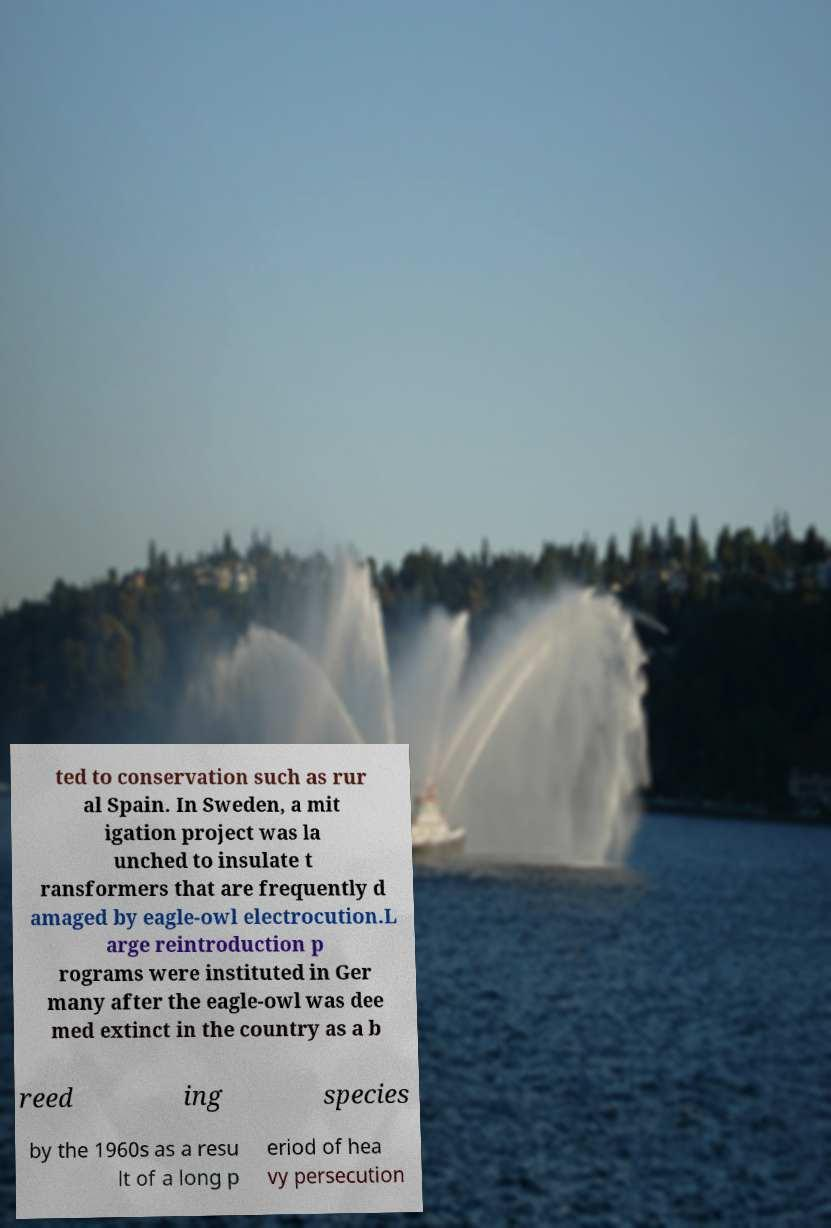Please read and relay the text visible in this image. What does it say? ted to conservation such as rur al Spain. In Sweden, a mit igation project was la unched to insulate t ransformers that are frequently d amaged by eagle-owl electrocution.L arge reintroduction p rograms were instituted in Ger many after the eagle-owl was dee med extinct in the country as a b reed ing species by the 1960s as a resu lt of a long p eriod of hea vy persecution 